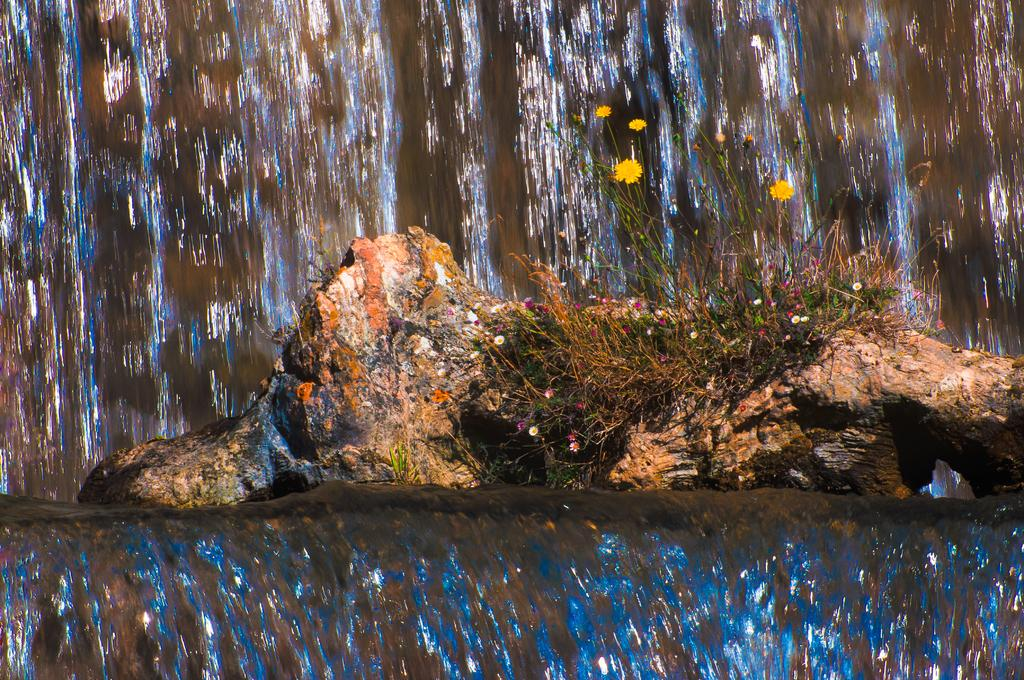What type of flora can be seen in the image? There are flowers and plants in the image. Where are the flowers and plants located? The flowers and plants are on a rock in the image. What natural feature is present in the background of the image? There is a waterfall in the image. What type of chess pieces can be seen on the rock in the image? There are no chess pieces present in the image; it features flowers, plants, and a waterfall. Is there any evidence of a crime scene in the image? There is no indication of a crime scene in the image; it is a natural scene with flowers, plants, and a waterfall. 